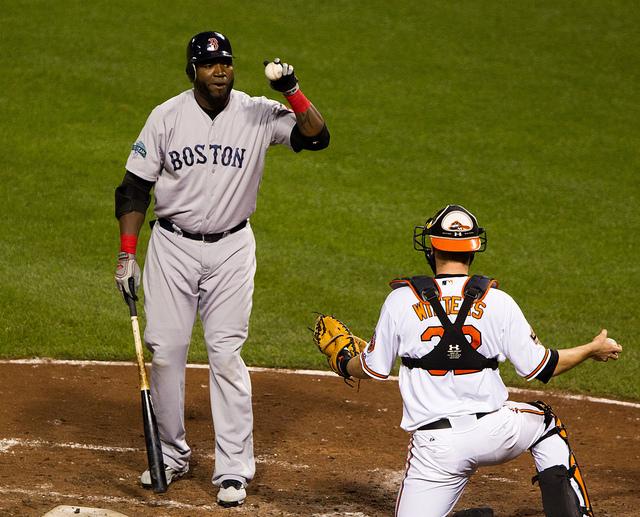What is the player in orange doing to the player in white?
Write a very short answer. Throwing ball. What team is up to bat?
Keep it brief. Boston. Why is the catcher reaching out?
Quick response, please. Catch. Who is on his knees?
Give a very brief answer. Catcher. What is the player in the back doing?
Answer briefly. Holding baseball. Is the batter ready to bat?
Quick response, please. No. What team is the batter on?
Keep it brief. Boston. 